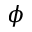<formula> <loc_0><loc_0><loc_500><loc_500>\phi</formula> 